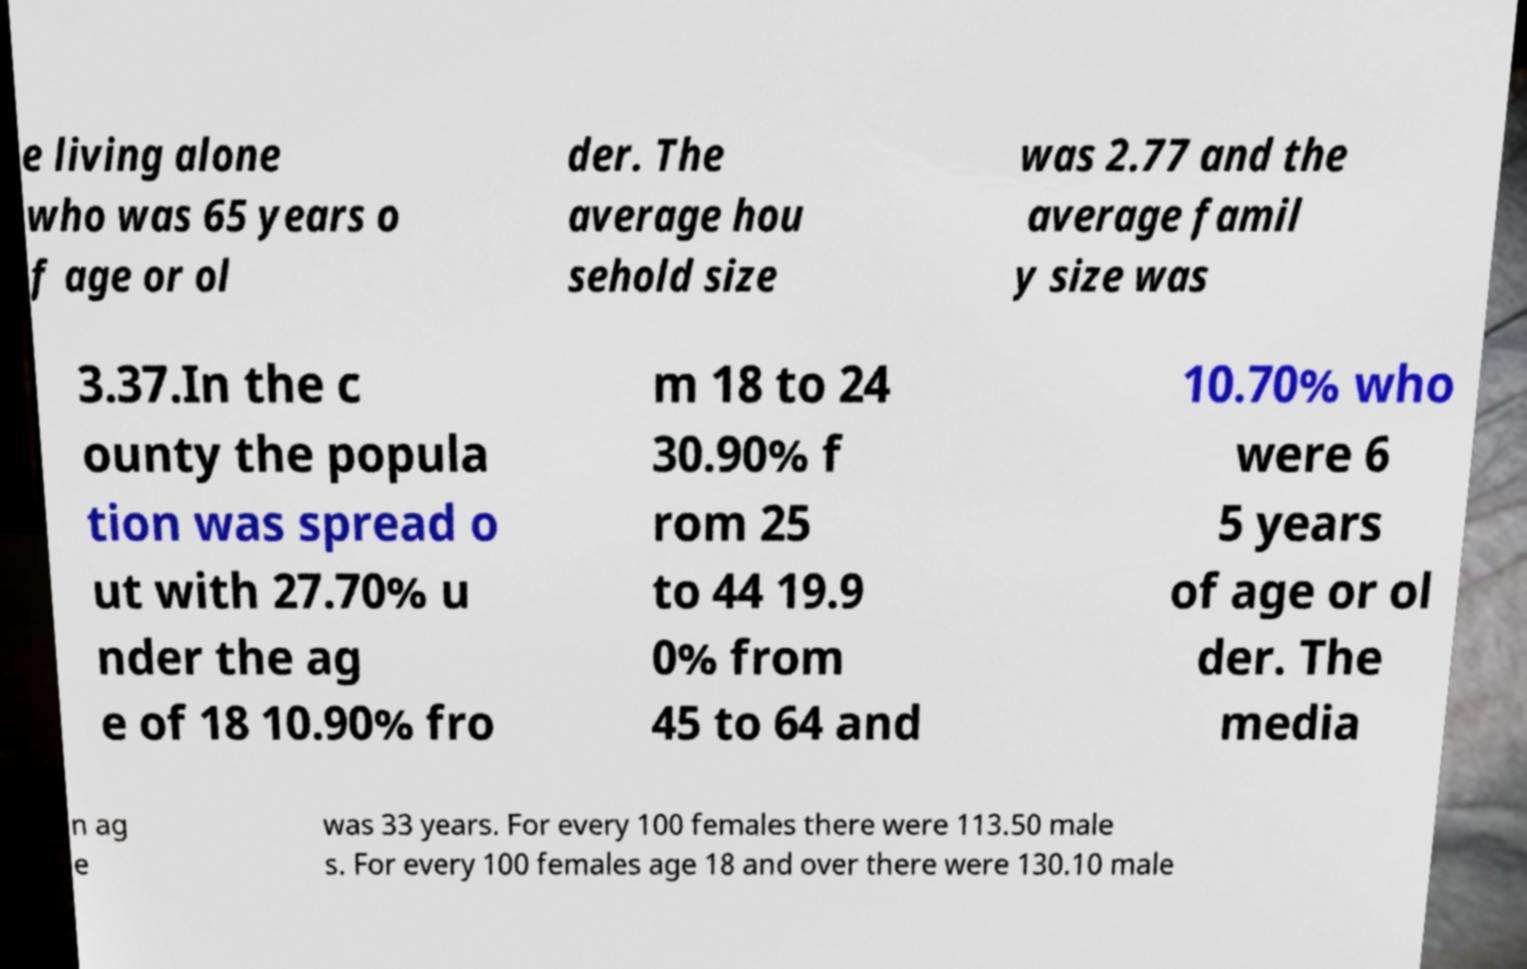Could you extract and type out the text from this image? e living alone who was 65 years o f age or ol der. The average hou sehold size was 2.77 and the average famil y size was 3.37.In the c ounty the popula tion was spread o ut with 27.70% u nder the ag e of 18 10.90% fro m 18 to 24 30.90% f rom 25 to 44 19.9 0% from 45 to 64 and 10.70% who were 6 5 years of age or ol der. The media n ag e was 33 years. For every 100 females there were 113.50 male s. For every 100 females age 18 and over there were 130.10 male 